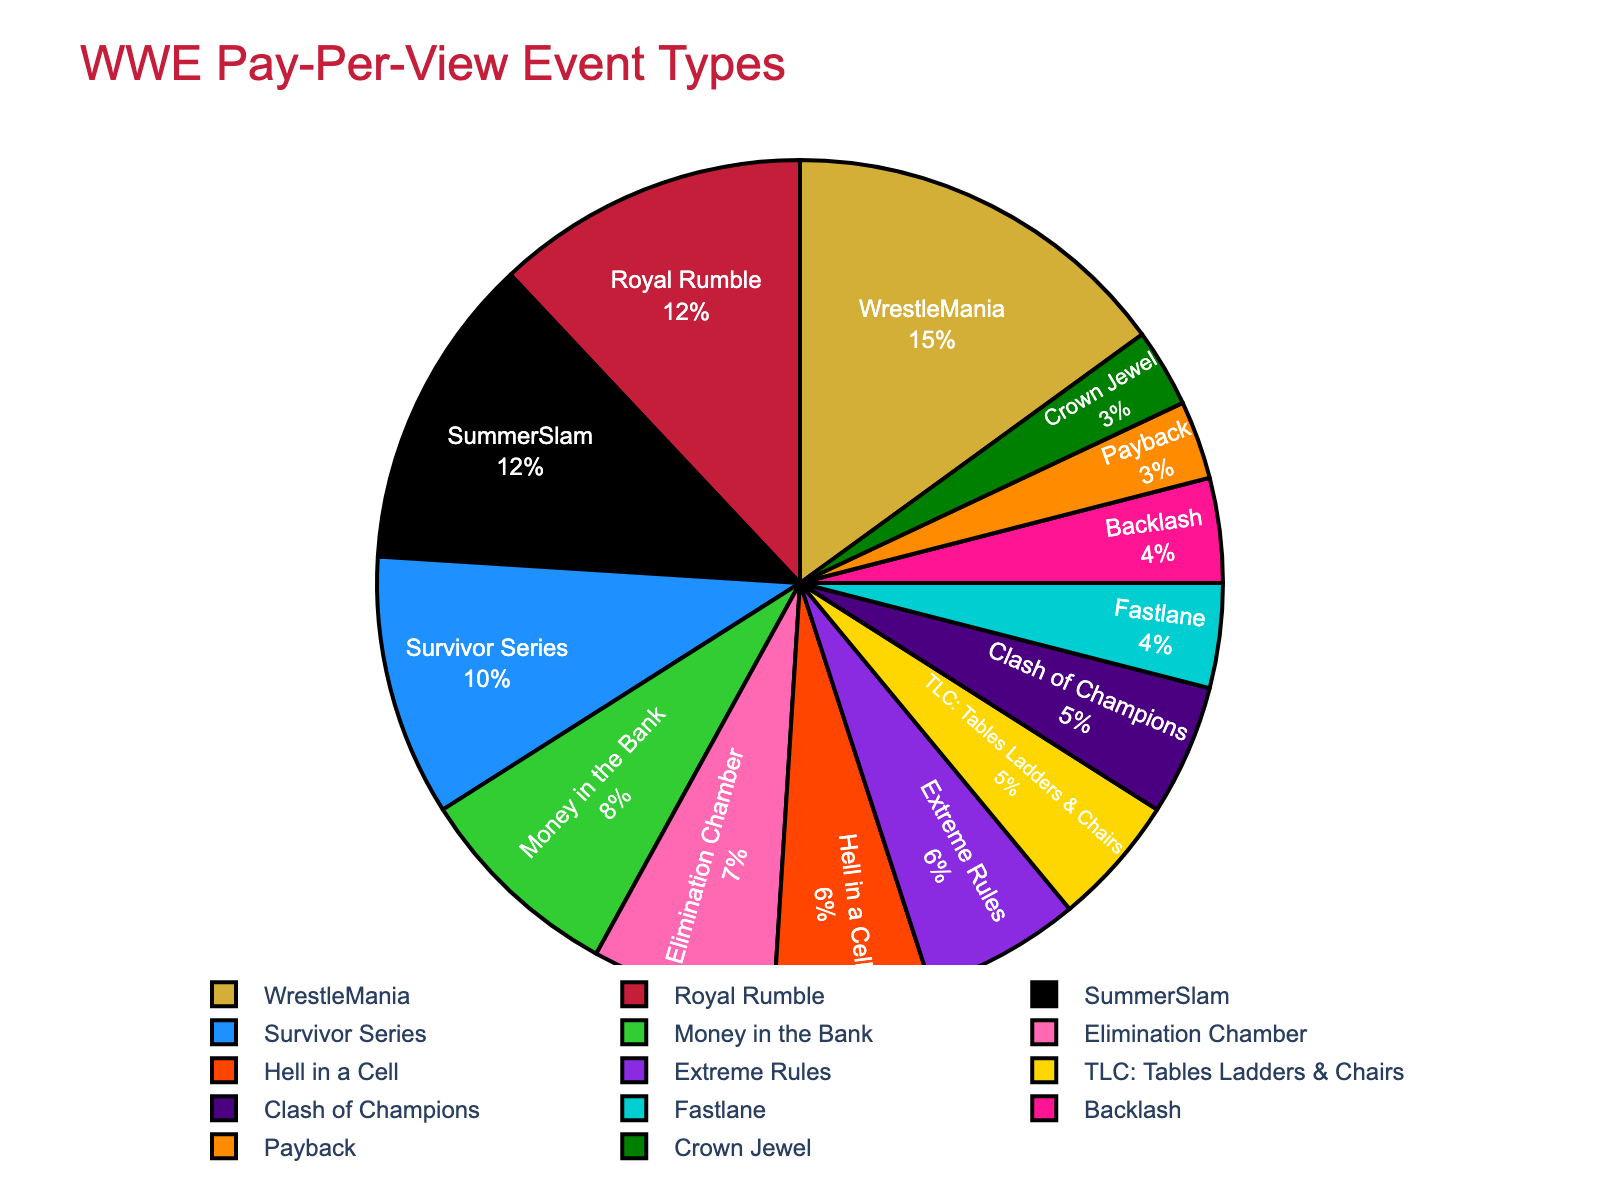What's the biggest pay-per-view event by percentage? WrestleMania has the largest segment in the pie chart, representing the highest percentage.
Answer: WrestleMania Which event types contribute equally to the total percentage? SummerSlam and Royal Rumble each contribute 12%; Hell in a Cell and Extreme Rules each contribute 6%; Clash of Champions and TLC each contribute 5%; Backlash and Fastlane each contribute 4%.
Answer: SummerSlam & Royal Rumble, Hell in a Cell & Extreme Rules, Clash of Champions & TLC, Backlash & Fastlane How much higher is WrestleMania's percentage compared to Money in the Bank? WrestleMania is 15%, and Money in the Bank is 8%, so the difference is 15% - 8% = 7%.
Answer: 7% What's the combined percentage of the top four events? The percentages for WrestleMania, Royal Rumble, SummerSlam, and Survivor Series are 15%, 12%, 12%, and 10% respectively. Combined, that’s 15% + 12% + 12% + 10% = 49%.
Answer: 49% Which events have a smaller percentage than Survivor Series but more than Payback? Survivor Series is 10%, and Payback is 3%. The events in between these percentages are Money in the Bank (8%), Elimination Chamber (7%), Hell in a Cell (6%), and Extreme Rules (6%).
Answer: Money in the Bank, Elimination Chamber, Hell in a Cell, Extreme Rules What is the average percentage of events that have a percentage of 5% or above? The events with 5% or above are WrestleMania (15%), Royal Rumble (12%), SummerSlam (12%), Survivor Series (10%), Money in the Bank (8%), Elimination Chamber (7%), Hell in a Cell (6%), Extreme Rules (6%), TLC (5%), Clash of Champions (5%). The sum is 86% and there are 10 such events, so the average is 86% / 10 = 8.6%.
Answer: 8.6% Which has a smaller percentage: Fastlane or Payback? Comparing the two, Fastlane is 4% and Payback is 3%. Therefore, Payback has a smaller percentage.
Answer: Payback How many events are there in total in the pie chart? By counting the segments listed in the data, there are 14 different WWE pay-per-view event types.
Answer: 14 What is the combined percentage of events that are less than 5%? The events less than 5% are Payback (3%) and Crown Jewel (3%). Combined, that’s 3% + 3% = 6%.
Answer: 6% Which event type visually appears as the smallest segment? The smallest segment in the pie chart by percentage is Payback and Crown Jewel, both at 3%.
Answer: Payback and Crown Jewel 